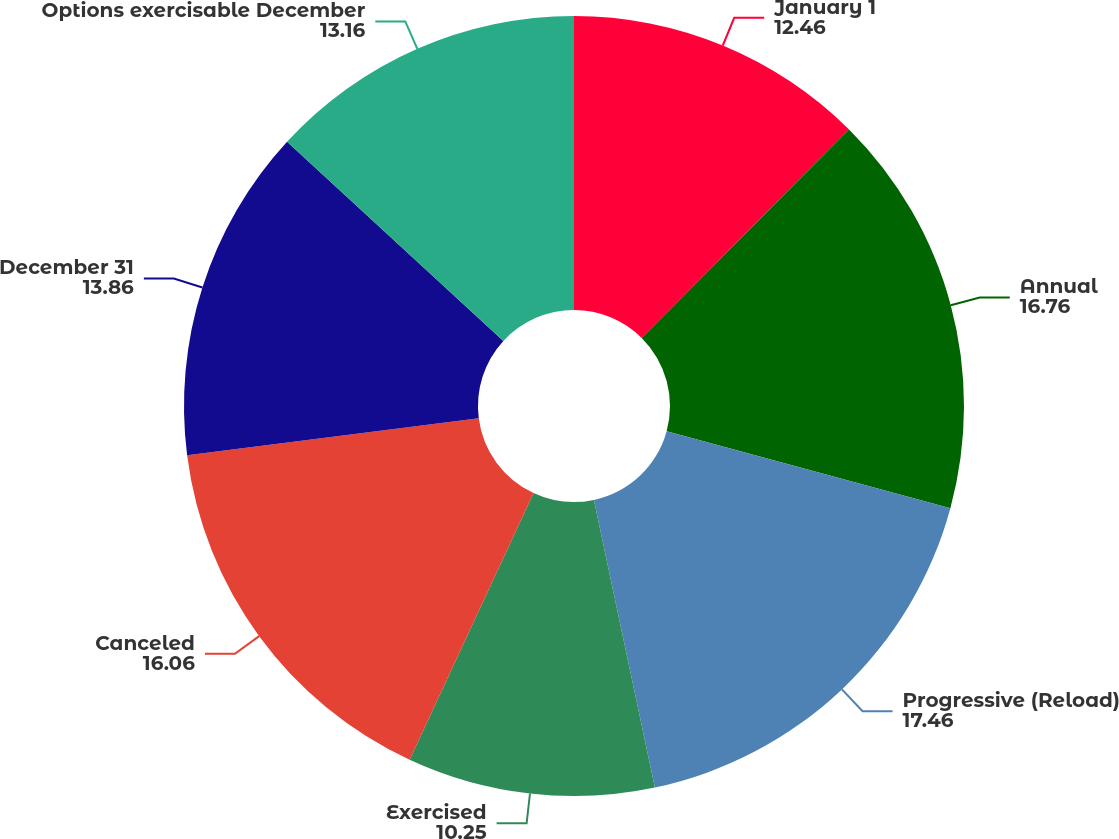Convert chart to OTSL. <chart><loc_0><loc_0><loc_500><loc_500><pie_chart><fcel>January 1<fcel>Annual<fcel>Progressive (Reload)<fcel>Exercised<fcel>Canceled<fcel>December 31<fcel>Options exercisable December<nl><fcel>12.46%<fcel>16.76%<fcel>17.46%<fcel>10.25%<fcel>16.06%<fcel>13.86%<fcel>13.16%<nl></chart> 